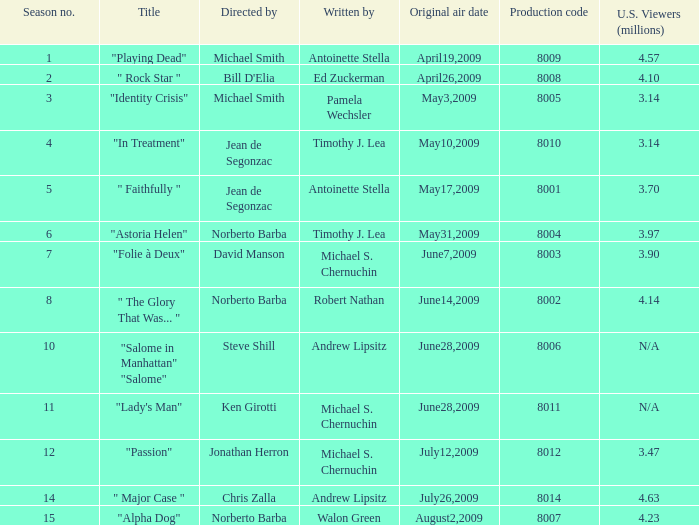Who are the writer of the series episode number 170? Walon Green. 